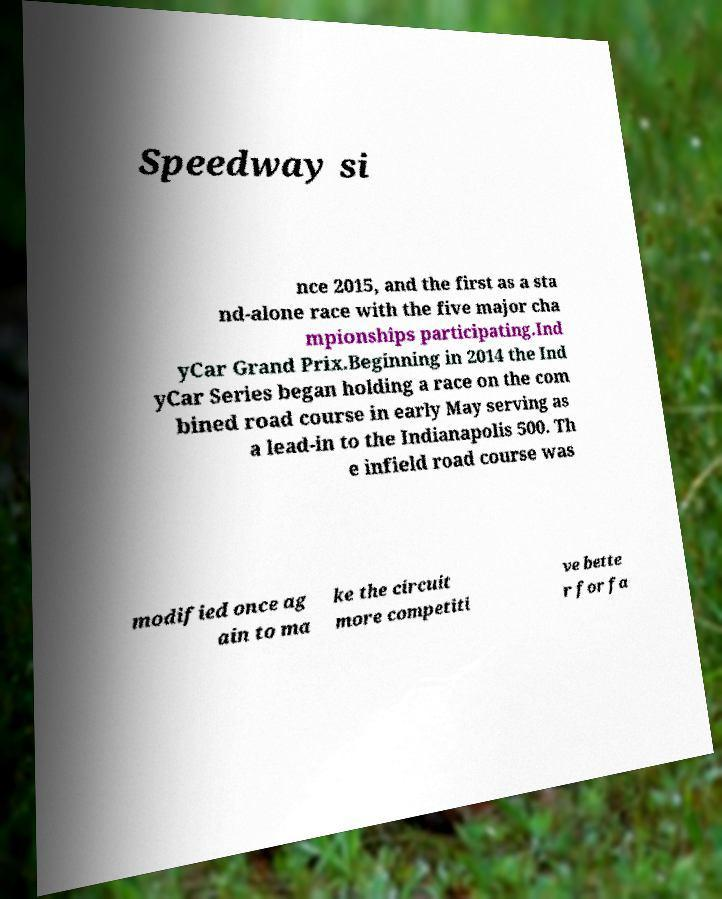Can you accurately transcribe the text from the provided image for me? Speedway si nce 2015, and the first as a sta nd-alone race with the five major cha mpionships participating.Ind yCar Grand Prix.Beginning in 2014 the Ind yCar Series began holding a race on the com bined road course in early May serving as a lead-in to the Indianapolis 500. Th e infield road course was modified once ag ain to ma ke the circuit more competiti ve bette r for fa 